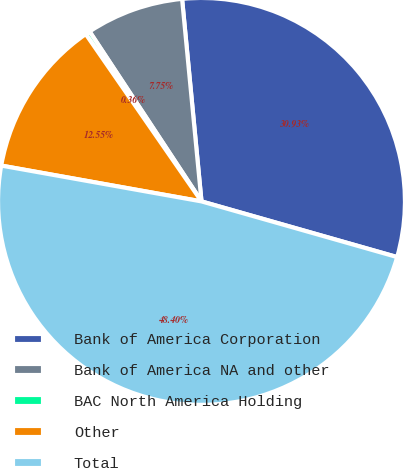Convert chart. <chart><loc_0><loc_0><loc_500><loc_500><pie_chart><fcel>Bank of America Corporation<fcel>Bank of America NA and other<fcel>BAC North America Holding<fcel>Other<fcel>Total<nl><fcel>30.93%<fcel>7.75%<fcel>0.36%<fcel>12.55%<fcel>48.4%<nl></chart> 